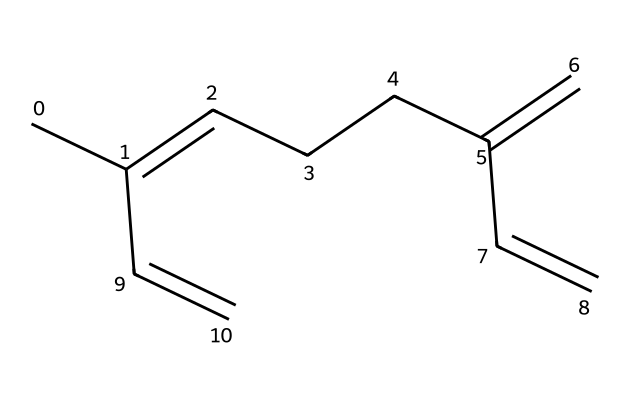What is the molecular formula of myrcene? To derive the molecular formula from the SMILES representation, count the carbon (C) and hydrogen (H) atoms present. The SMILES indicates there are 10 carbon atoms and 16 hydrogen atoms, leading to the formula C10H16.
Answer: C10H16 How many double bonds are present in myrcene? By analyzing the structure from the SMILES, the presence of double bonds can be identified. In this case, there are three double bonds in the molecule, evident from the '=' signs in the SMILES.
Answer: 3 What is the functional group represented in myrcene? The double bonds in this molecule indicate that it belongs to the class of compounds known as alkenes. Since it is a terpene, which is essentially a subclass of terpenes containing unsaturated bonds, the functional group is classified as an alkene.
Answer: alkene What type of isomerism can myrcene exhibit? Myrcene, with its multiple double bonds and distinct arrangements of carbon atoms, can exhibit geometric isomerism (cis/trans isomerism) due to its double bonds, particularly where substituents are differently oriented around those bonds.
Answer: geometric isomerism What is the relevance of myrcene to athletes? Myrcene is known for its presence in mangoes, which are often consumed by athletes for hydration. Its potential health benefits, such as anti-inflammatory properties, make it relevant to their dietary choices.
Answer: hydration 